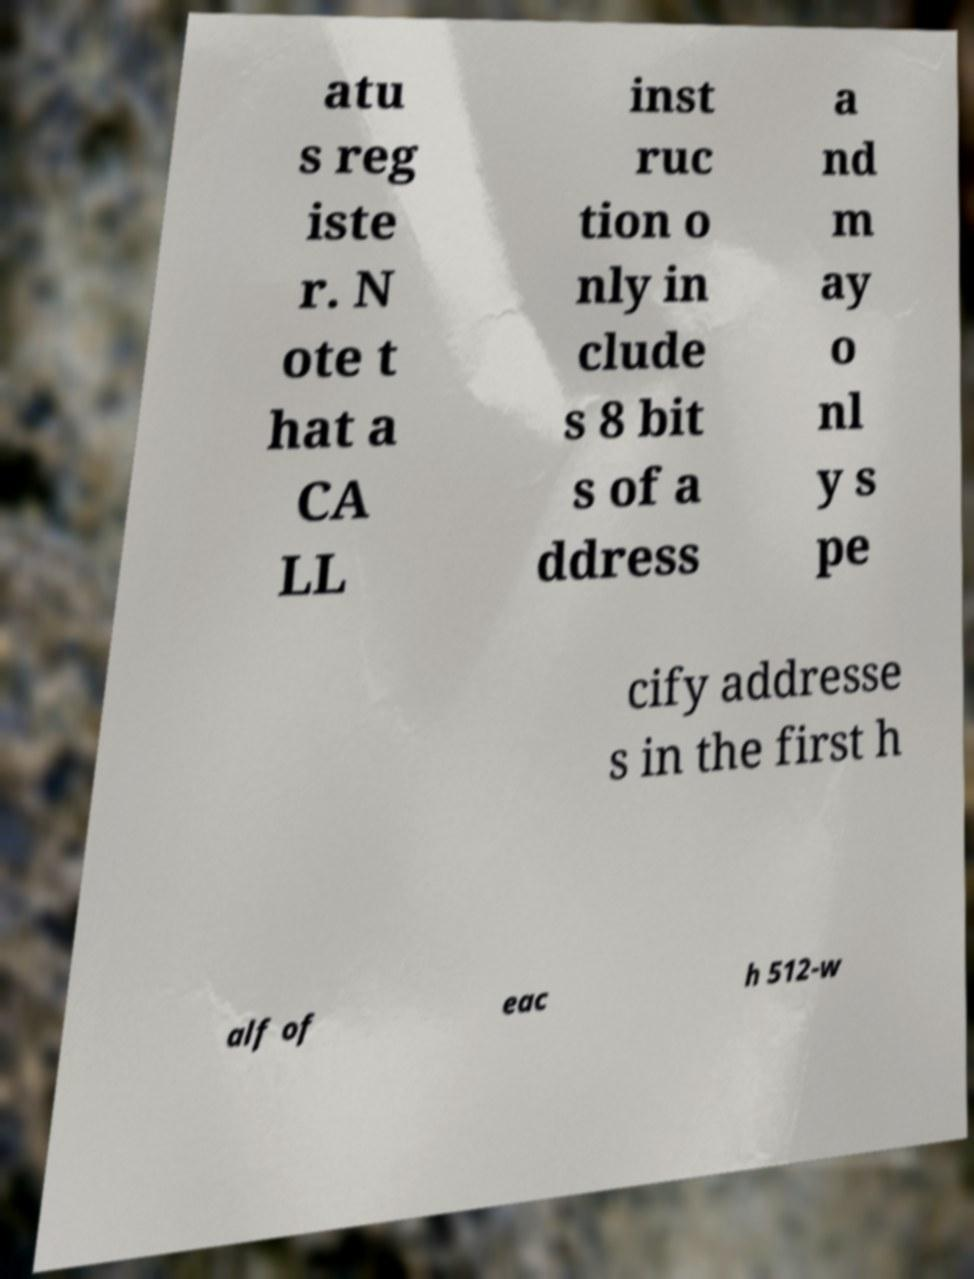Can you read and provide the text displayed in the image?This photo seems to have some interesting text. Can you extract and type it out for me? atu s reg iste r. N ote t hat a CA LL inst ruc tion o nly in clude s 8 bit s of a ddress a nd m ay o nl y s pe cify addresse s in the first h alf of eac h 512-w 